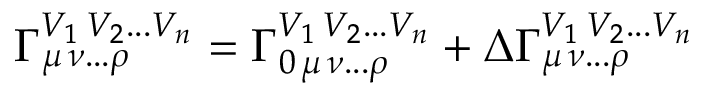<formula> <loc_0><loc_0><loc_500><loc_500>\Gamma _ { \mu \, \nu \dots \rho } ^ { V _ { 1 } \, V _ { 2 } \dots V _ { n } } = \Gamma _ { 0 \, \mu \, \nu \dots \rho } ^ { V _ { 1 } \, V _ { 2 } \dots V _ { n } } + \Delta \Gamma _ { \mu \, \nu \dots \rho } ^ { V _ { 1 } \, V _ { 2 } \dots V _ { n } }</formula> 